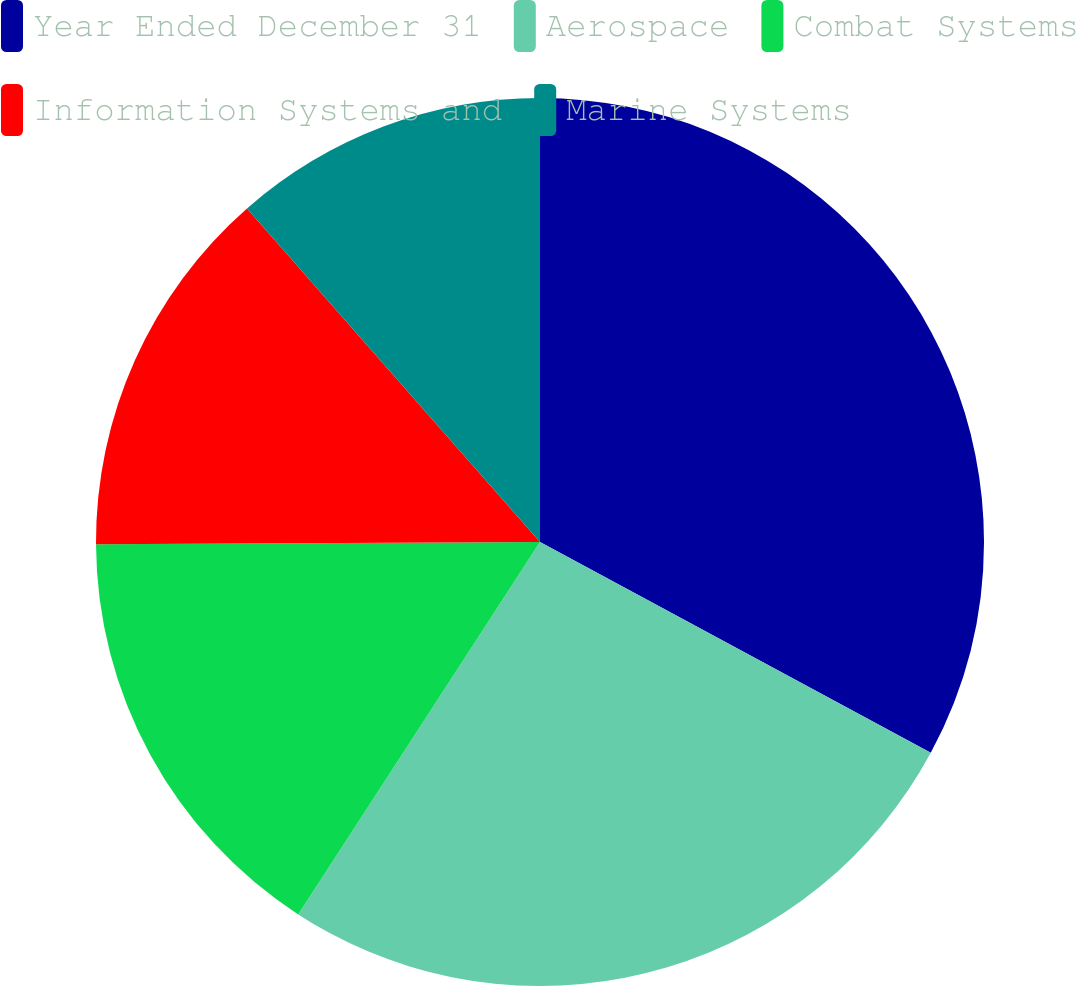Convert chart to OTSL. <chart><loc_0><loc_0><loc_500><loc_500><pie_chart><fcel>Year Ended December 31<fcel>Aerospace<fcel>Combat Systems<fcel>Information Systems and<fcel>Marine Systems<nl><fcel>32.87%<fcel>26.29%<fcel>15.75%<fcel>13.61%<fcel>11.47%<nl></chart> 